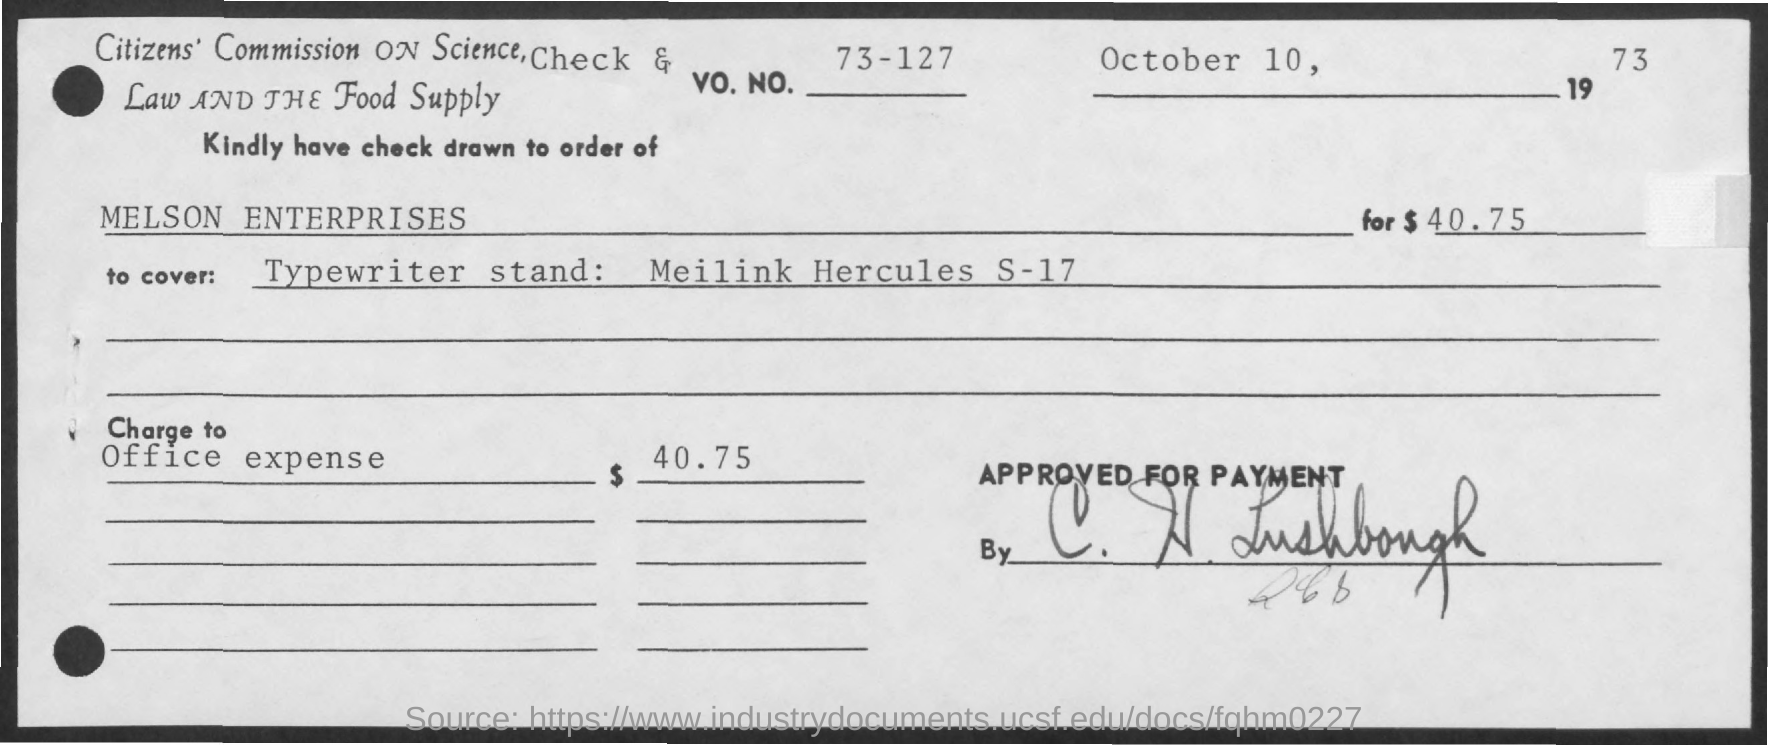What is the date mentioned in the given form ?
Your response must be concise. October 10, 1973. What is the vo.no. mentioned ?
Keep it short and to the point. 73-127. What is the amount mentioned in the given form ?
Provide a short and direct response. 40 75. 